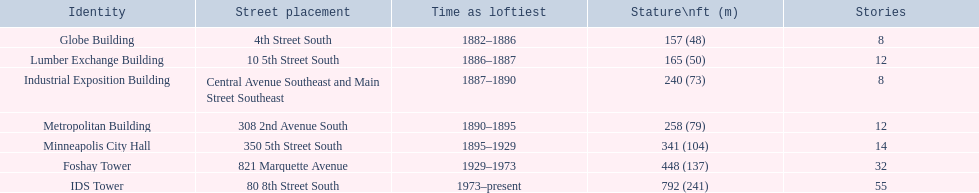Which buildings have the same number of floors as another building? Globe Building, Lumber Exchange Building, Industrial Exposition Building, Metropolitan Building. Of those, which has the same as the lumber exchange building? Metropolitan Building. 